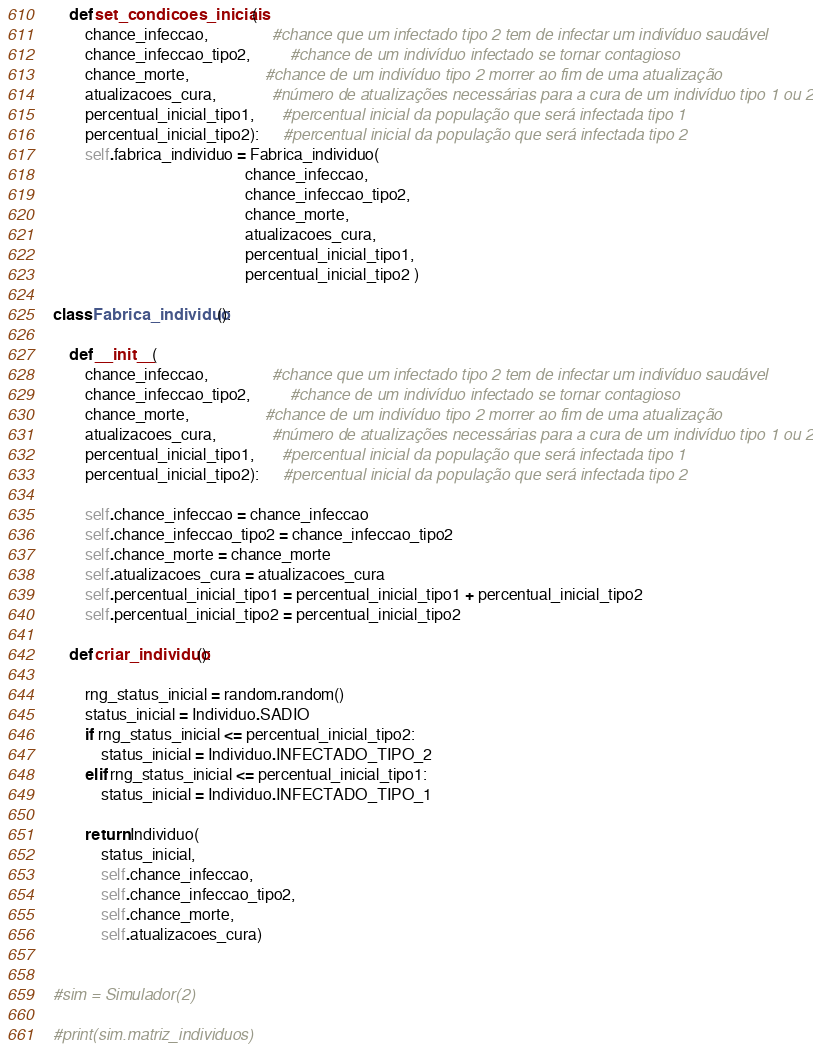<code> <loc_0><loc_0><loc_500><loc_500><_Python_>
    def set_condicoes_iniciais(
        chance_infeccao,                #chance que um infectado tipo 2 tem de infectar um indivíduo saudável
        chance_infeccao_tipo2,          #chance de um indivíduo infectado se tornar contagioso
        chance_morte,                   #chance de um indivíduo tipo 2 morrer ao fim de uma atualização
        atualizacoes_cura,              #número de atualizações necessárias para a cura de um indivíduo tipo 1 ou 2
        percentual_inicial_tipo1,       #percentual inicial da população que será infectada tipo 1
        percentual_inicial_tipo2):      #percentual inicial da população que será infectada tipo 2
        self.fabrica_individuo = Fabrica_individuo(
                                                chance_infeccao,
                                                chance_infeccao_tipo2, 
                                                chance_morte, 
                                                atualizacoes_cura, 
                                                percentual_inicial_tipo1, 
                                                percentual_inicial_tipo2 )

class Fabrica_individuo():
    
    def __init__(
        chance_infeccao,                #chance que um infectado tipo 2 tem de infectar um indivíduo saudável
        chance_infeccao_tipo2,          #chance de um indivíduo infectado se tornar contagioso
        chance_morte,                   #chance de um indivíduo tipo 2 morrer ao fim de uma atualização
        atualizacoes_cura,              #número de atualizações necessárias para a cura de um indivíduo tipo 1 ou 2
        percentual_inicial_tipo1,       #percentual inicial da população que será infectada tipo 1
        percentual_inicial_tipo2):      #percentual inicial da população que será infectada tipo 2

        self.chance_infeccao = chance_infeccao
        self.chance_infeccao_tipo2 = chance_infeccao_tipo2
        self.chance_morte = chance_morte
        self.atualizacoes_cura = atualizacoes_cura
        self.percentual_inicial_tipo1 = percentual_inicial_tipo1 + percentual_inicial_tipo2
        self.percentual_inicial_tipo2 = percentual_inicial_tipo2

    def criar_individuo():

        rng_status_inicial = random.random()
        status_inicial = Individuo.SADIO        
        if rng_status_inicial <= percentual_inicial_tipo2:
            status_inicial = Individuo.INFECTADO_TIPO_2
        elif rng_status_inicial <= percentual_inicial_tipo1:
            status_inicial = Individuo.INFECTADO_TIPO_1
        
        return Individuo(
            status_inicial, 
            self.chance_infeccao, 
            self.chance_infeccao_tipo2, 
            self.chance_morte, 
            self.atualizacoes_cura)


#sim = Simulador(2)

#print(sim.matriz_individuos)</code> 